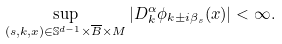<formula> <loc_0><loc_0><loc_500><loc_500>\sup _ { ( s , k , x ) \in \mathbb { S } ^ { d - 1 } \times \overline { B } \times M } | D ^ { \alpha } _ { k } \phi _ { k \pm i \beta _ { s } } ( x ) | < \infty .</formula> 